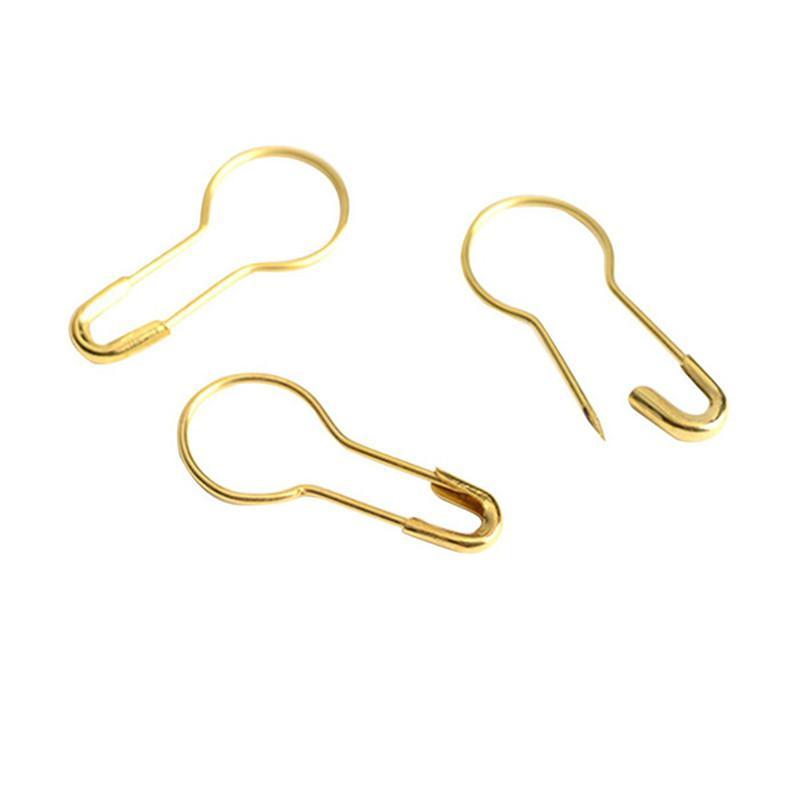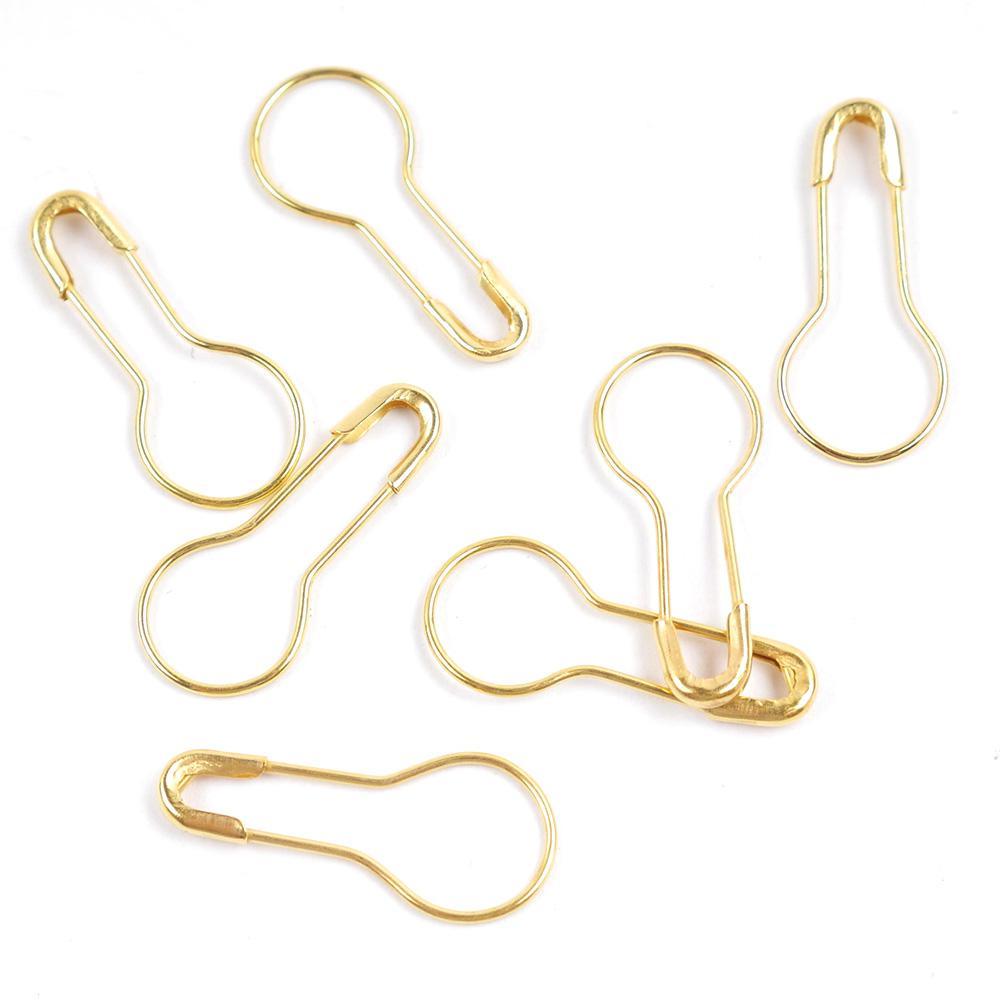The first image is the image on the left, the second image is the image on the right. For the images shown, is this caption "There are more pins in the image on the right than in the image on the left." true? Answer yes or no. Yes. The first image is the image on the left, the second image is the image on the right. Evaluate the accuracy of this statement regarding the images: "All pins in each image are the same color and all have a large circular end opposite the clasp end.". Is it true? Answer yes or no. Yes. 